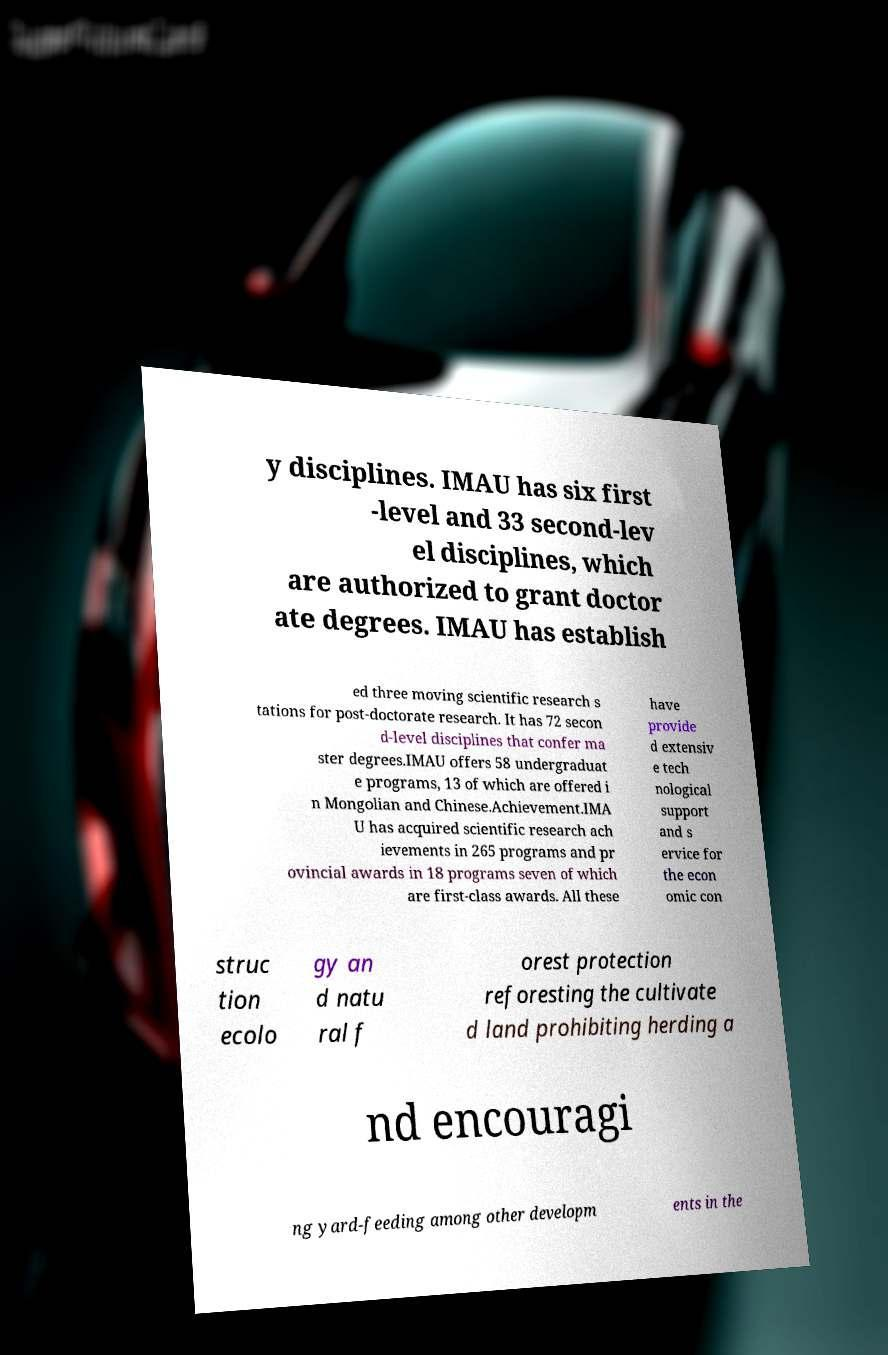Could you assist in decoding the text presented in this image and type it out clearly? y disciplines. IMAU has six first -level and 33 second-lev el disciplines, which are authorized to grant doctor ate degrees. IMAU has establish ed three moving scientific research s tations for post-doctorate research. It has 72 secon d-level disciplines that confer ma ster degrees.IMAU offers 58 undergraduat e programs, 13 of which are offered i n Mongolian and Chinese.Achievement.IMA U has acquired scientific research ach ievements in 265 programs and pr ovincial awards in 18 programs seven of which are first-class awards. All these have provide d extensiv e tech nological support and s ervice for the econ omic con struc tion ecolo gy an d natu ral f orest protection reforesting the cultivate d land prohibiting herding a nd encouragi ng yard-feeding among other developm ents in the 